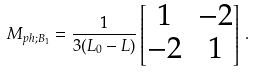<formula> <loc_0><loc_0><loc_500><loc_500>M _ { p h ; B _ { 1 } } = \frac { 1 } { 3 ( L _ { 0 } - L ) } \begin{bmatrix} 1 & - 2 \\ - 2 & 1 \end{bmatrix} \, .</formula> 